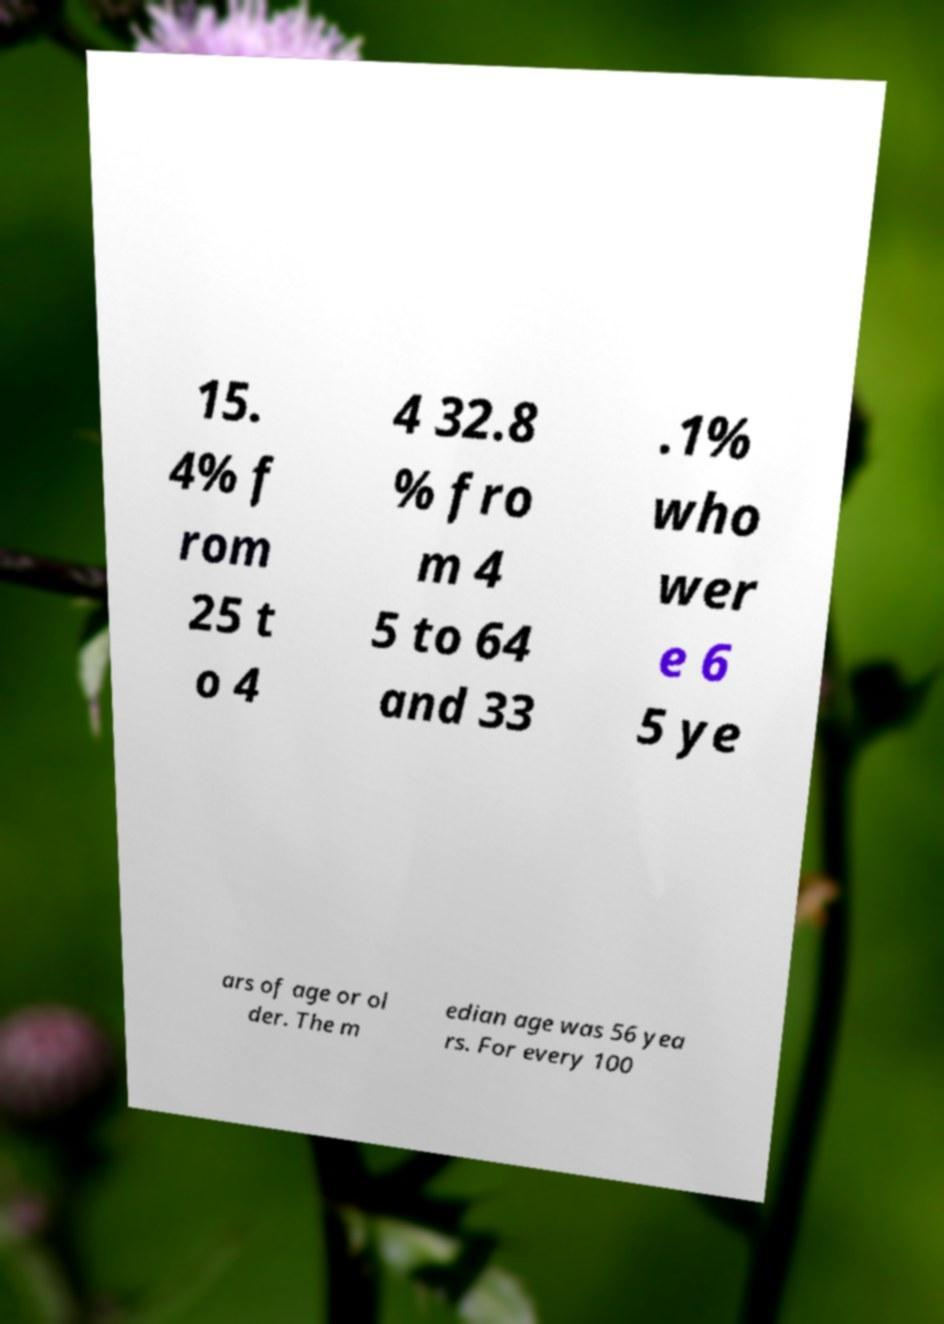Could you extract and type out the text from this image? 15. 4% f rom 25 t o 4 4 32.8 % fro m 4 5 to 64 and 33 .1% who wer e 6 5 ye ars of age or ol der. The m edian age was 56 yea rs. For every 100 